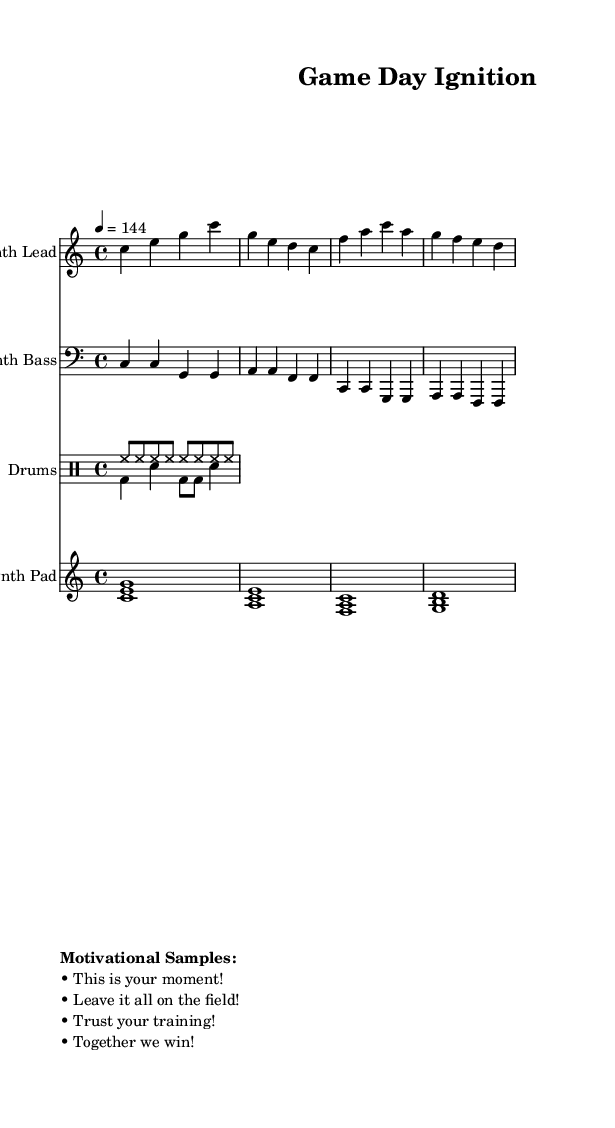What is the key signature of this music? The key signature is indicated at the beginning of the score with no sharps or flats, which corresponds to C major.
Answer: C major What is the time signature of this music? The time signature is shown at the beginning of the score. It is represented as "4/4", meaning there are four beats in a measure and a quarter note gets one beat.
Answer: 4/4 What is the tempo marking for this music? The tempo marking is located just below the title, indicated as "4 = 144". This indicates the speed at which the piece should be played, with quarter notes receiving 144 beats per minute.
Answer: 144 What instruments are featured in this piece? The instruments are listed at the beginning of each staff. They include "Synth Lead", "Synth Bass", "Drums", and "Synth Pad".
Answer: Synth Lead, Synth Bass, Drums, Synth Pad What type of music is this piece designed for? The piece is categorized as "Soundtracks", and specifically structured with motivational speech samples, making it ideal for energizing pre-game warm-ups.
Answer: Upbeat electronic music How many measures are there in the Synth Lead? The Synth Lead is composed of 2 measures as visually grouped within the score. Each measure contains a specific number of beats aligned with the 4/4 time signature.
Answer: 2 measures What are the motivational speech samples included? The samples are listed under a "Motivational Samples" heading, which includes four phrases designed to inspire players. The phrases are: "This is your moment!", "Leave it all on the field!", "Trust your training!", and "Together we win!".
Answer: This is your moment!, Leave it all on the field!, Trust your training!, Together we win! 